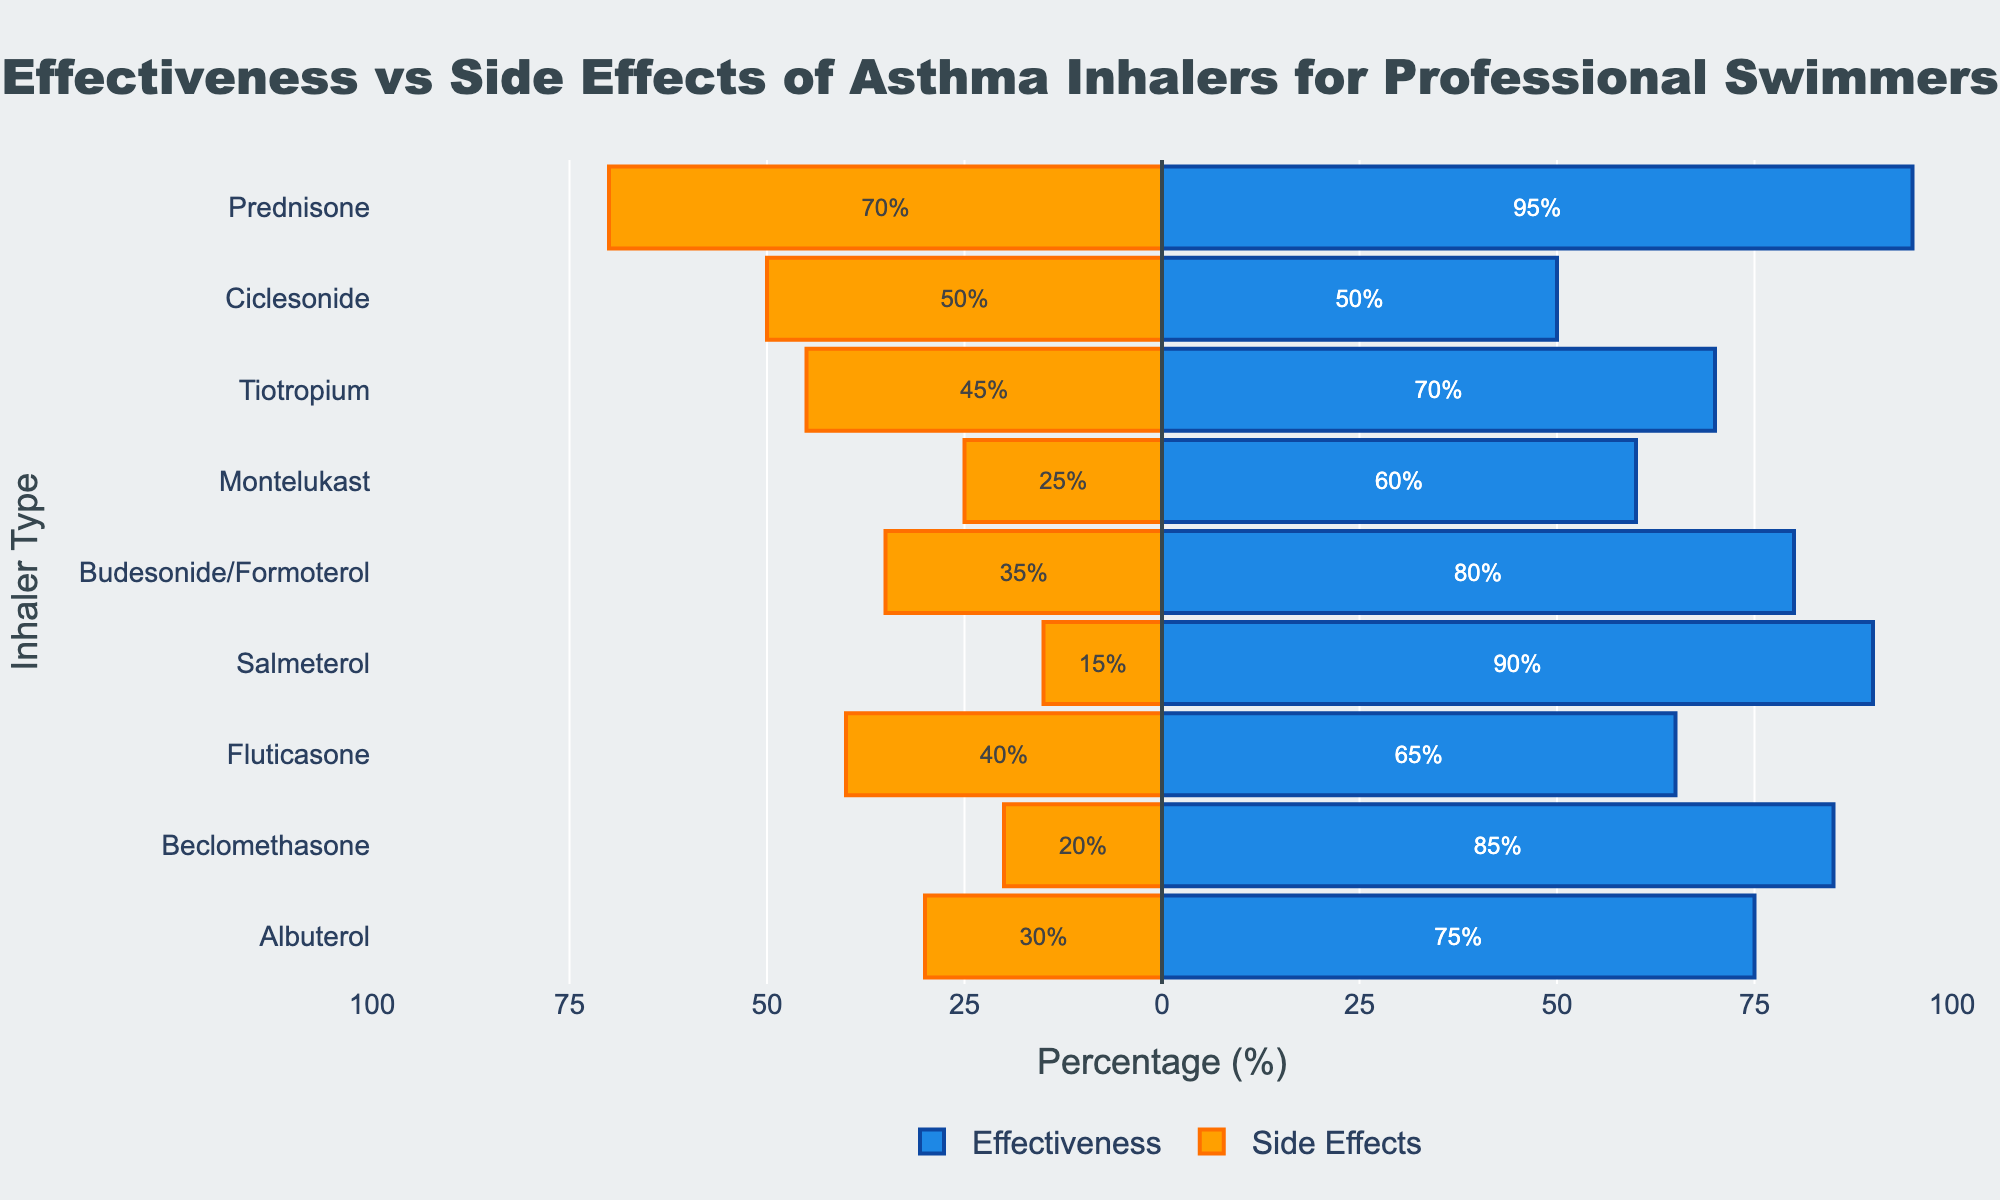Which inhaler shows the highest effectiveness? The bar with the longest length on the positive side indicates the one with the highest effectiveness. Prednisone has the highest effectiveness at 95%.
Answer: Prednisone Which inhaler has the highest side effect category, and what is it? The bar with the greatest negative length represents the highest side effect. Prednisone has the highest side effect at 70%, categorized as Very High.
Answer: Prednisone, Very High Between Tiotropium and Fluticasone, which inhaler has a higher effectiveness and by how much? Tiotropium's effectiveness is 70%, whereas Fluticasone's effectiveness is 65%. The difference is 70% - 65% = 5%.
Answer: Tiotropium, 5% What is the average effectiveness of inhalers categorized as "High" in effectiveness? The inhalers with "High" effectiveness are Albuterol (75%), Beclomethasone (85%), Salmeterol (90%), Budesonide/Formoterol (80%), and Prednisone (95%). The average is calculated as (75 + 85 + 90 + 80 + 95) / 5 = 85%.
Answer: 85% Which inhaler has the lowest side effects, and what percentage is it? By looking at the smallest negative value, Salmeterol has the lowest side effects at 15%.
Answer: Salmeterol, 15% Among the inhalers with a "Moderate" effectiveness category, which one has the highest side effects? The inhalers with "Moderate" effectiveness are Fluticasone (40%), Montelukast (25%), and Tiotropium (45%). Tiotropium has the highest side effects at 45%.
Answer: Tiotropium How many inhalers have a "Low" effectiveness category? By examining the effectiveness and its category, only Ciclesonide has a "Low" effectiveness category. Hence, there is only one inhaler in this category.
Answer: 1 Compare the side effects of Salmeterol and Montelukast, which one is lower and by how much? Salmeterol has side effects of 15%, and Montelukast has 25%. The difference is 25% - 15% = 10%.
Answer: Salmeterol, 10% Which inhaler type falls into the "Moderate" side effects category while having a "High" effectiveness category? The inhalers in the "High" effectiveness category are Albuterol, Beclomethasone, Salmeterol, Budesonide/Formoterol, and Prednisone. Among these, Albuterol and Budesonide/Formoterol fall into the "Moderate" side effects category.
Answer: Albuterol, Budesonide/Formoterol What's the combined average of effectiveness and side effects for Beclomethasone? Beclomethasone's effectiveness is 85% and side effects are 20%. The average is calculated as (85 + 20) / 2 = 52.5%.
Answer: 52.5% 